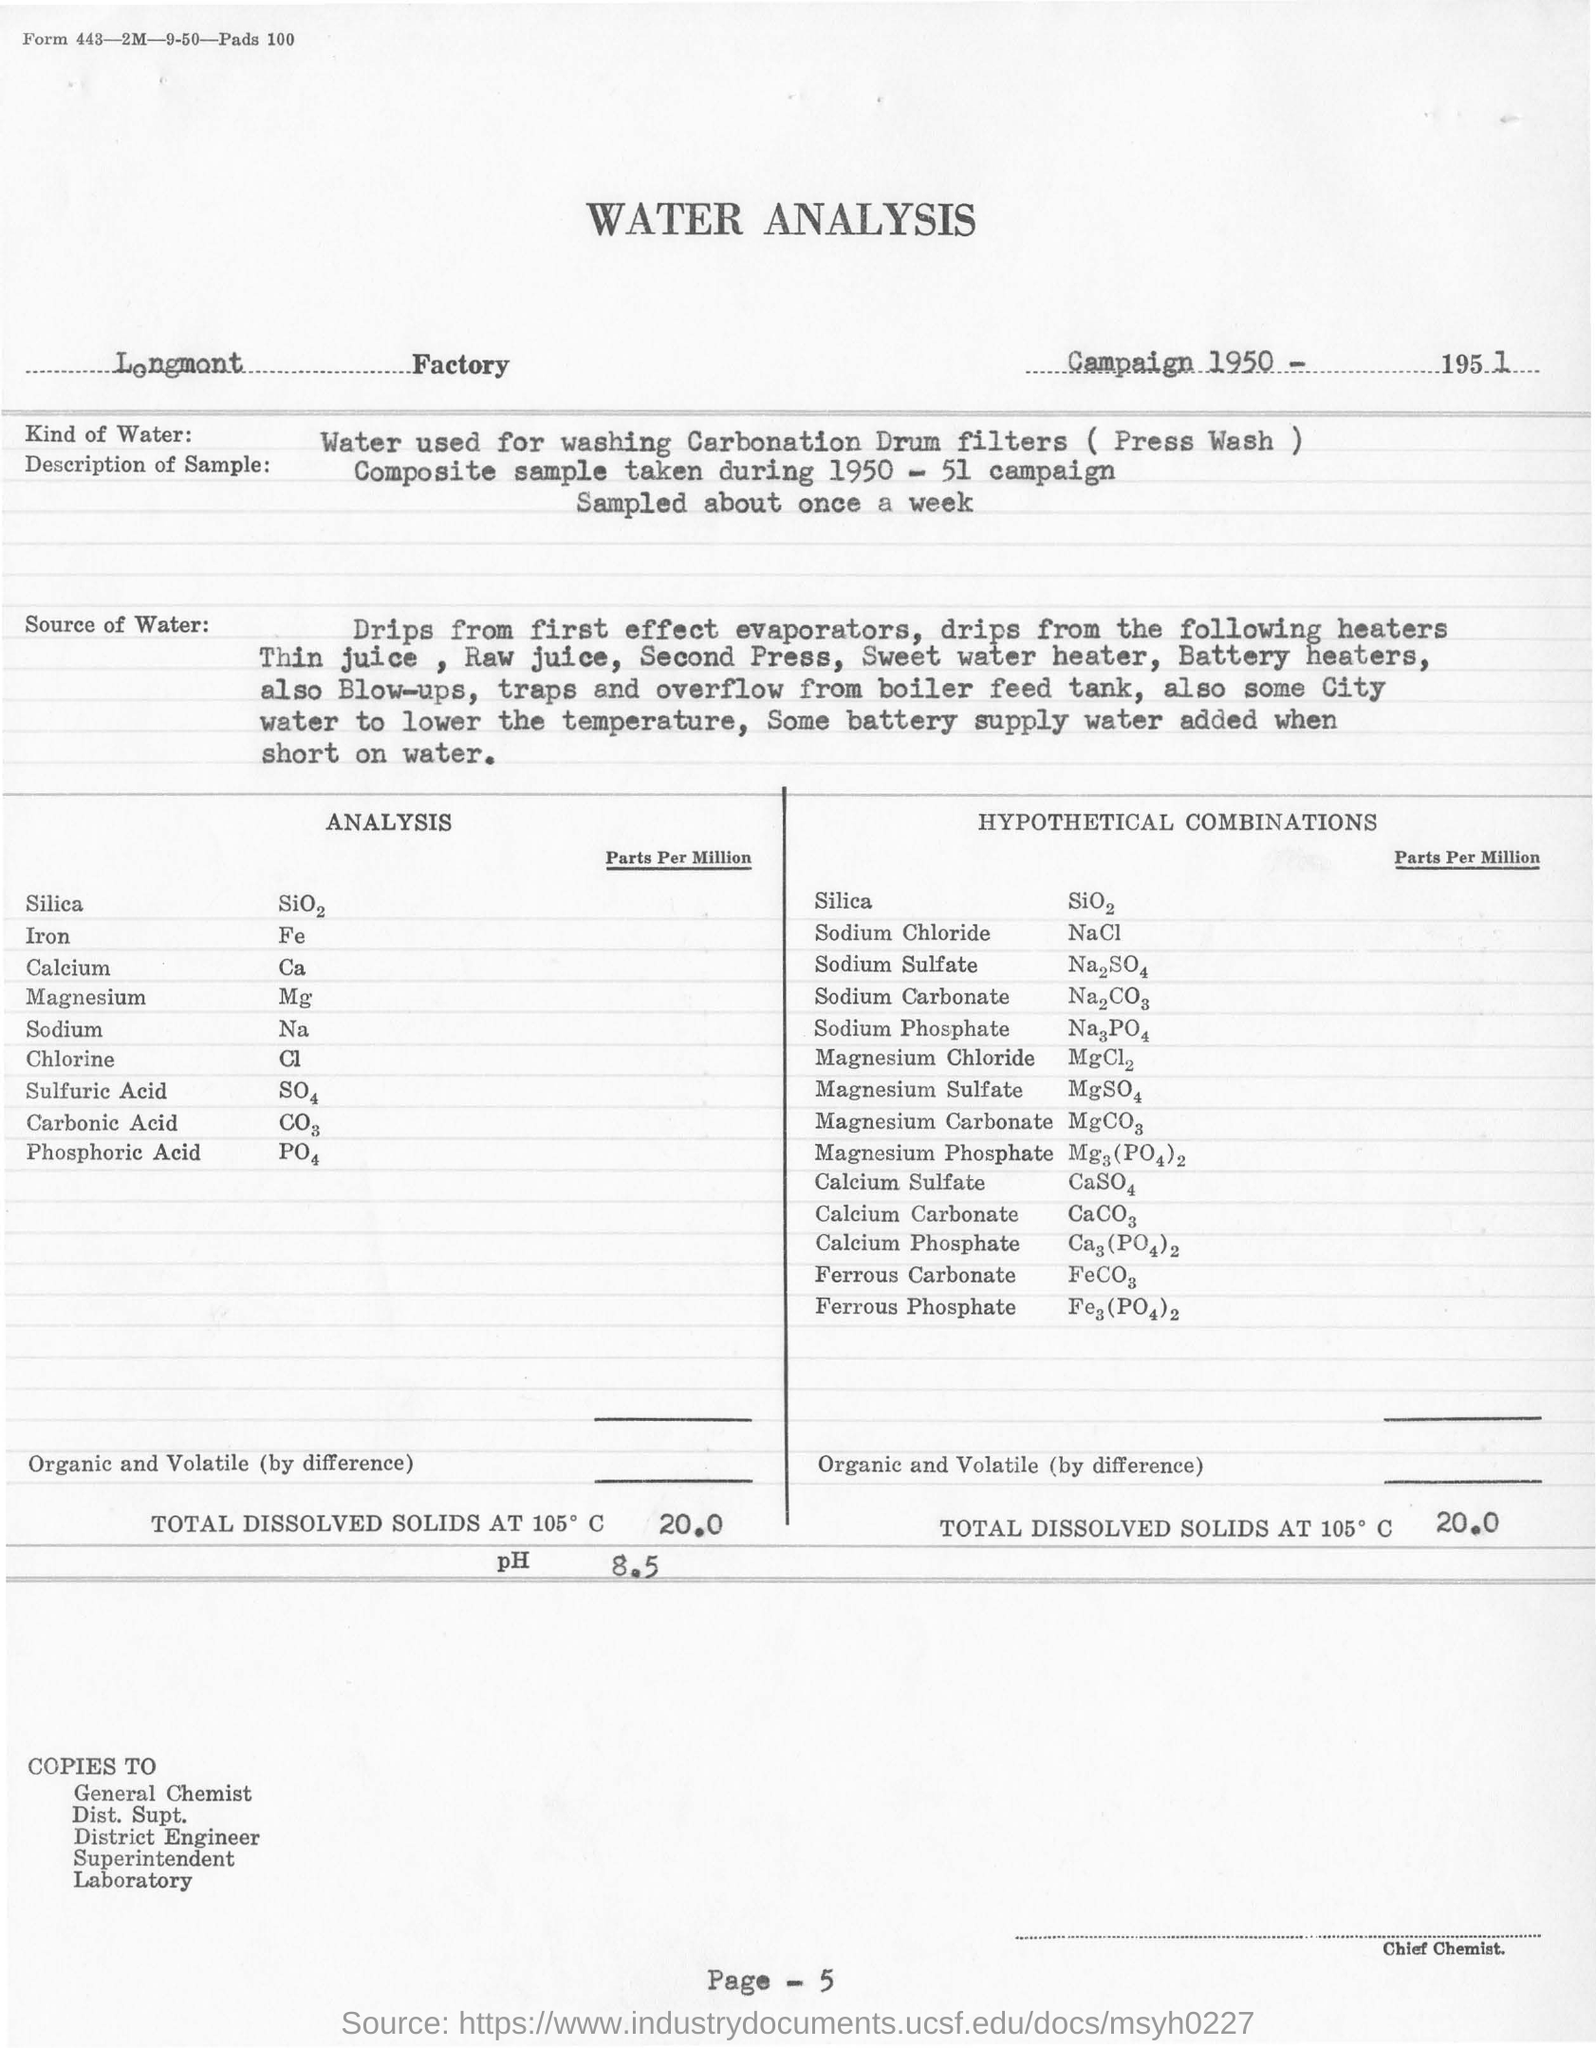In which Factory is the analysis conducted?
Provide a succinct answer. Longmont factory. What kind of water is used for analysis?
Your response must be concise. Water used for washing Carbonation Drum filters ( Press Wash ). What is the page no mentioned in this document?
Offer a terse response. Page - 5. 